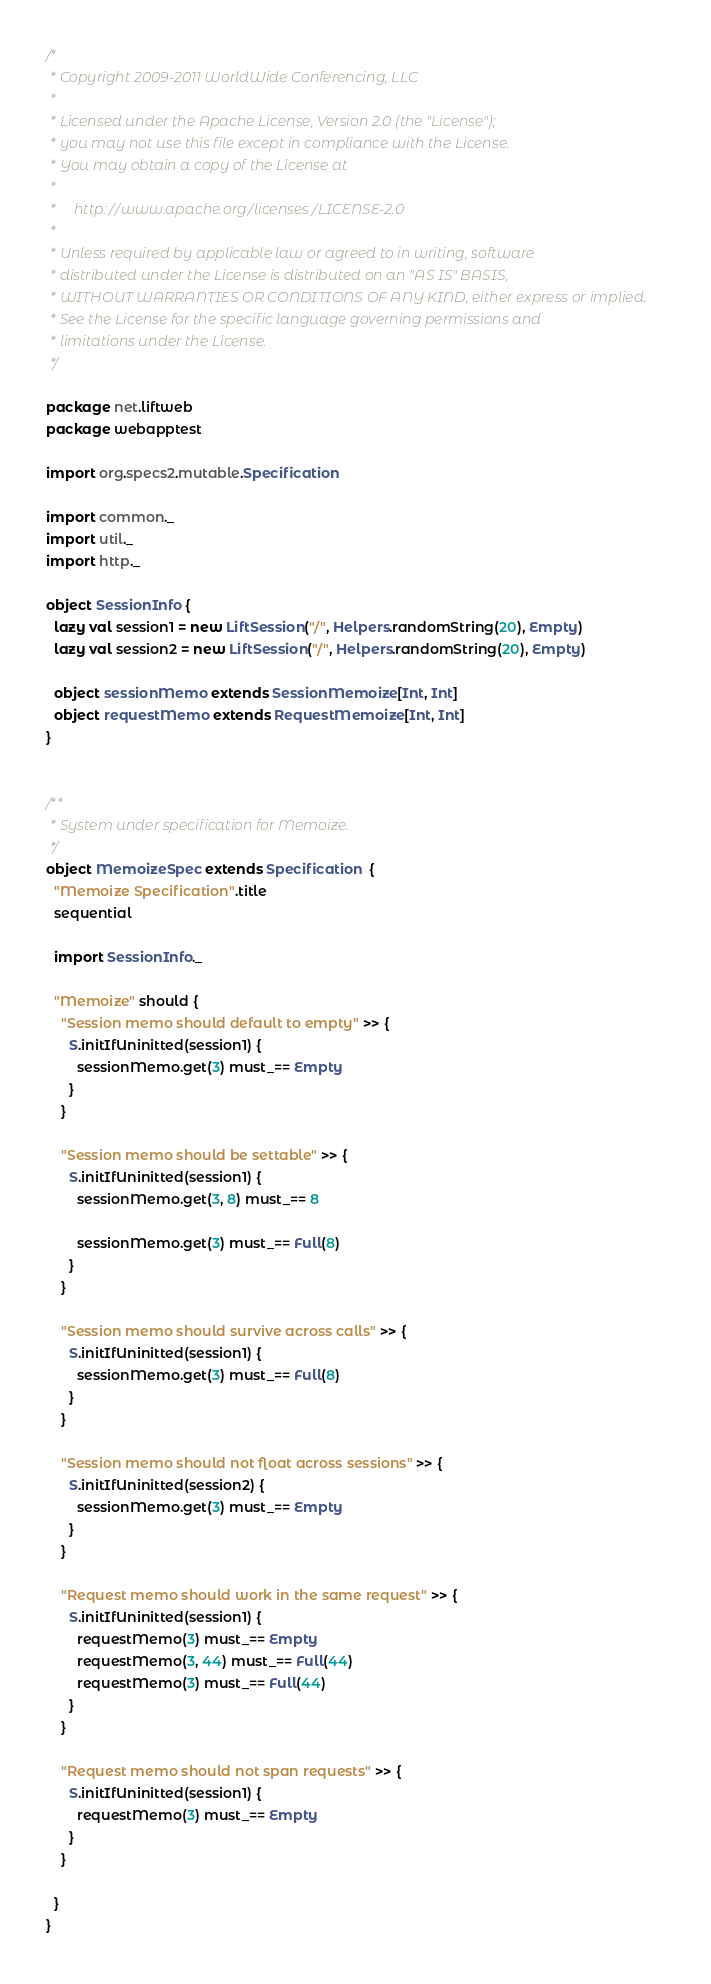<code> <loc_0><loc_0><loc_500><loc_500><_Scala_>/*
 * Copyright 2009-2011 WorldWide Conferencing, LLC
 *
 * Licensed under the Apache License, Version 2.0 (the "License");
 * you may not use this file except in compliance with the License.
 * You may obtain a copy of the License at
 *
 *     http://www.apache.org/licenses/LICENSE-2.0
 *
 * Unless required by applicable law or agreed to in writing, software
 * distributed under the License is distributed on an "AS IS" BASIS,
 * WITHOUT WARRANTIES OR CONDITIONS OF ANY KIND, either express or implied.
 * See the License for the specific language governing permissions and
 * limitations under the License.
 */

package net.liftweb
package webapptest

import org.specs2.mutable.Specification

import common._
import util._
import http._

object SessionInfo {
  lazy val session1 = new LiftSession("/", Helpers.randomString(20), Empty)
  lazy val session2 = new LiftSession("/", Helpers.randomString(20), Empty)

  object sessionMemo extends SessionMemoize[Int, Int]
  object requestMemo extends RequestMemoize[Int, Int]
}


/**
 * System under specification for Memoize.
 */
object MemoizeSpec extends Specification  {
  "Memoize Specification".title
  sequential

  import SessionInfo._

  "Memoize" should {
    "Session memo should default to empty" >> {
      S.initIfUninitted(session1) {
        sessionMemo.get(3) must_== Empty
      }
    }

    "Session memo should be settable" >> {
      S.initIfUninitted(session1) {
        sessionMemo.get(3, 8) must_== 8

        sessionMemo.get(3) must_== Full(8)
      }
    }

    "Session memo should survive across calls" >> {
      S.initIfUninitted(session1) {
        sessionMemo.get(3) must_== Full(8)
      }
    }

    "Session memo should not float across sessions" >> {
      S.initIfUninitted(session2) {
        sessionMemo.get(3) must_== Empty
      }
    }

    "Request memo should work in the same request" >> {
      S.initIfUninitted(session1) {
        requestMemo(3) must_== Empty
        requestMemo(3, 44) must_== Full(44)
        requestMemo(3) must_== Full(44)
      }
    }

    "Request memo should not span requests" >> {
      S.initIfUninitted(session1) {
        requestMemo(3) must_== Empty
      }
    }

  }
}

</code> 